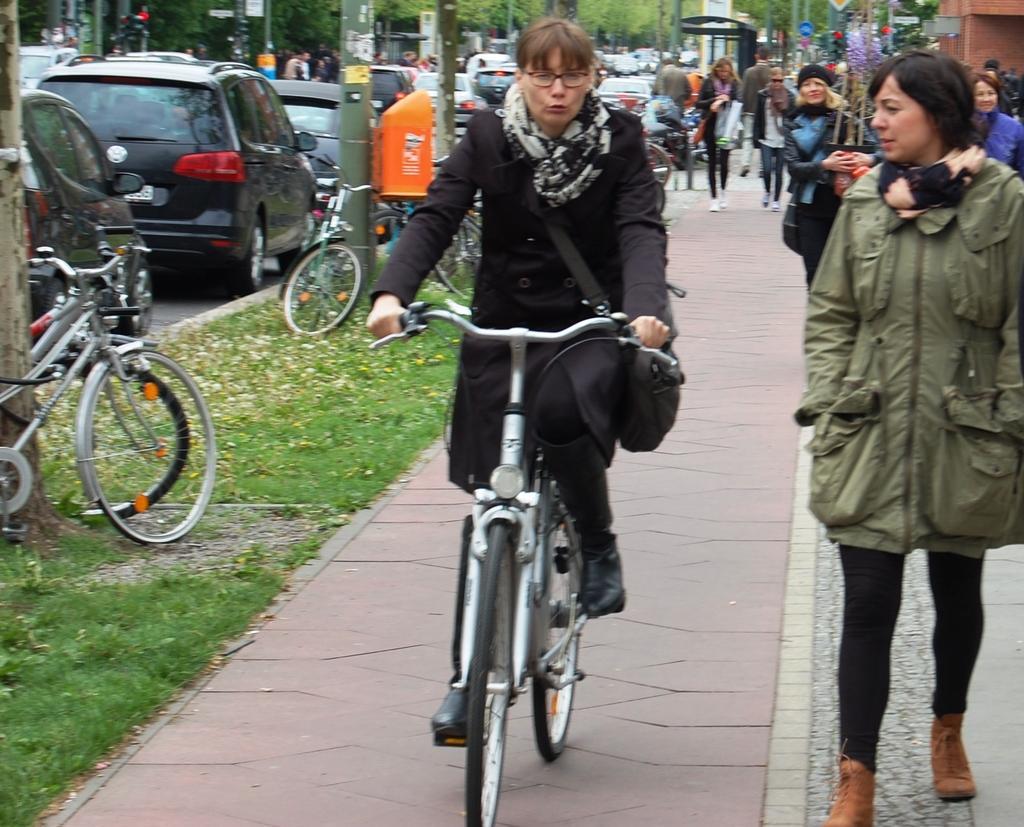Can you describe this image briefly? It is a Footpath , a woman is riding a bicycle there are also a lot of people behind and beside her, to the left the grass on the footpath beside that there are a lot of cars, the background are also lot of trees and other vehicles. 